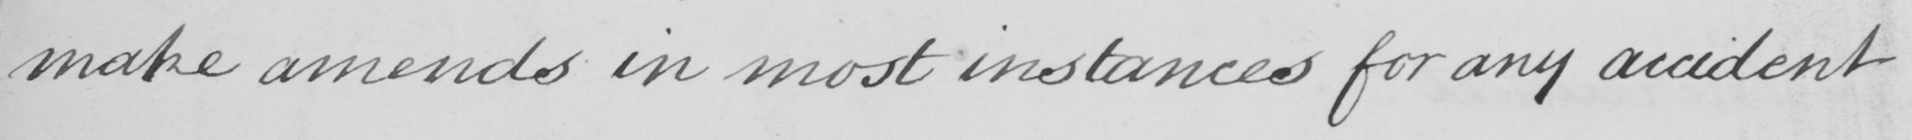Can you read and transcribe this handwriting? make amends in most instances for any accident 